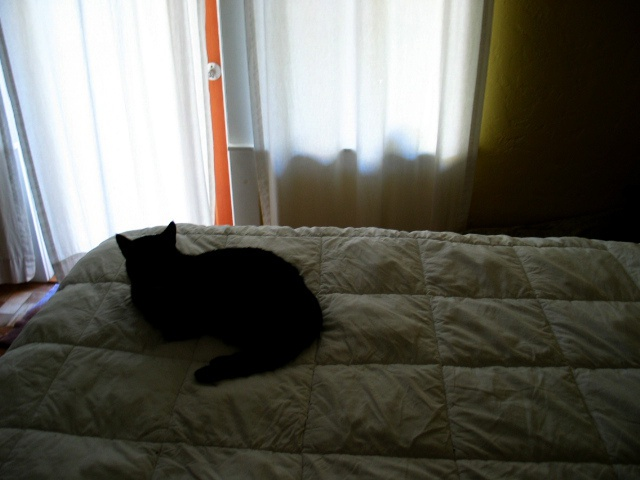Describe the objects in this image and their specific colors. I can see bed in lightblue, black, and gray tones and cat in lightblue, black, and gray tones in this image. 